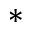Convert formula to latex. <formula><loc_0><loc_0><loc_500><loc_500>\ast</formula> 